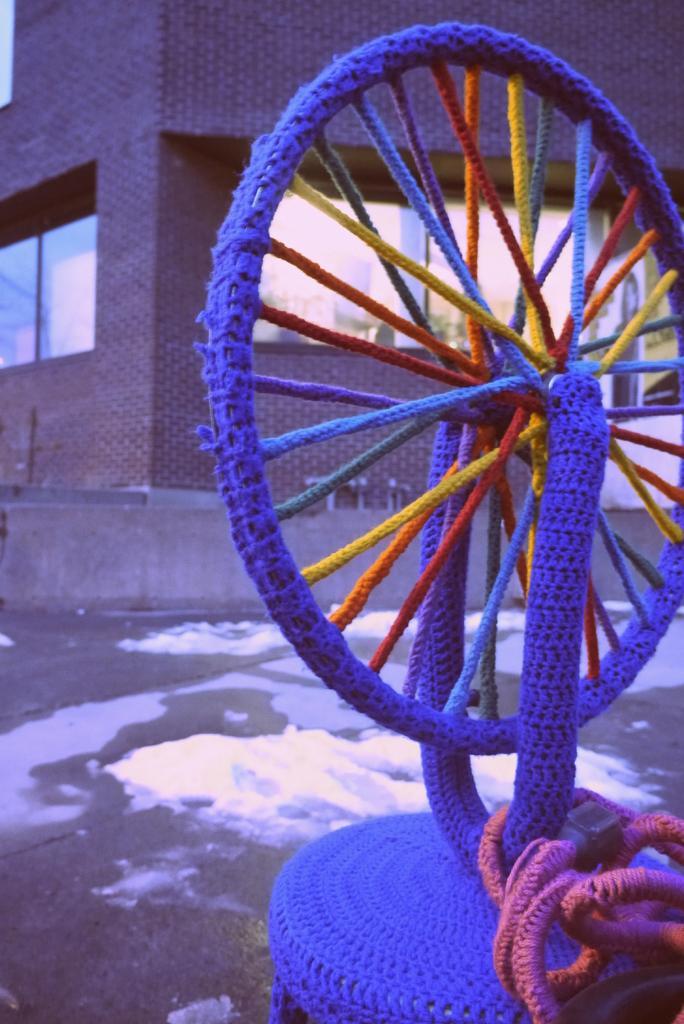Please provide a concise description of this image. In this image we can see a wheel covered with the different colors of thread, in the background there is a building. 